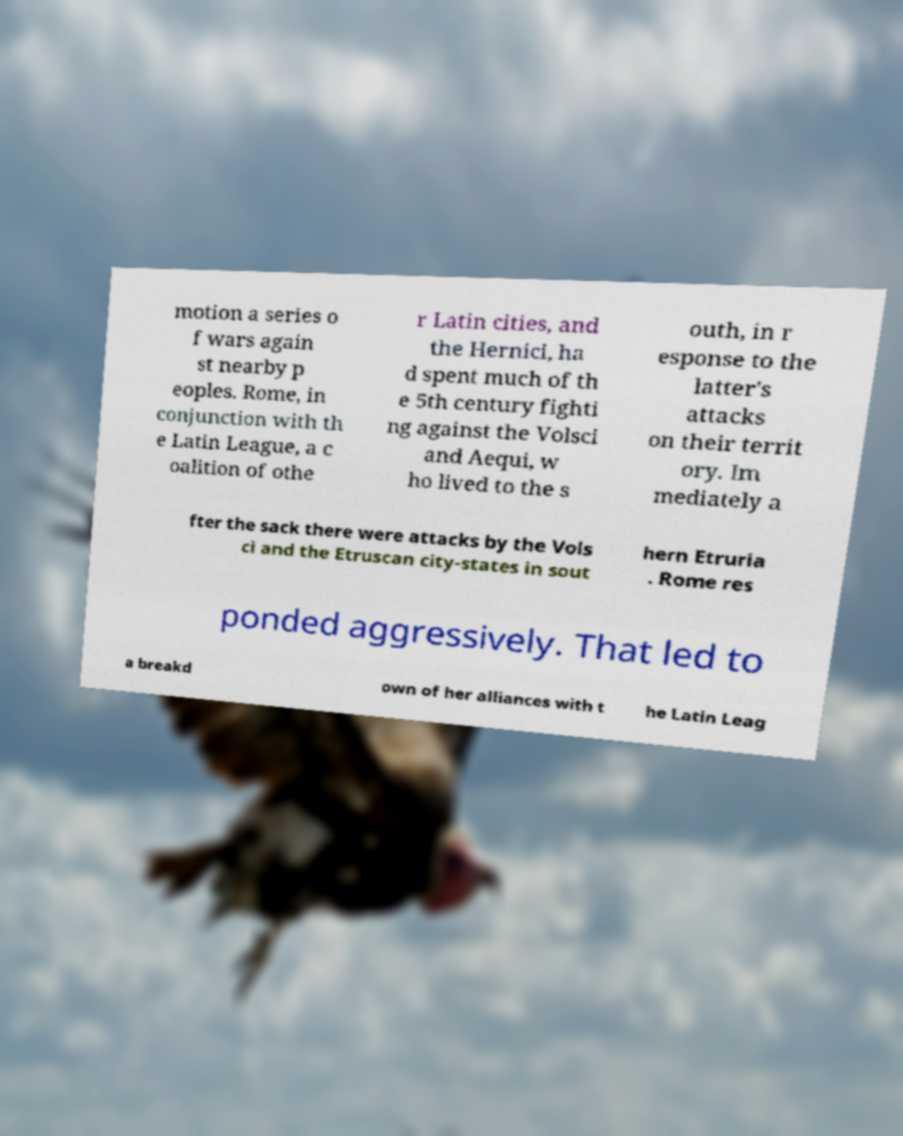Can you accurately transcribe the text from the provided image for me? motion a series o f wars again st nearby p eoples. Rome, in conjunction with th e Latin League, a c oalition of othe r Latin cities, and the Hernici, ha d spent much of th e 5th century fighti ng against the Volsci and Aequi, w ho lived to the s outh, in r esponse to the latter's attacks on their territ ory. Im mediately a fter the sack there were attacks by the Vols ci and the Etruscan city-states in sout hern Etruria . Rome res ponded aggressively. That led to a breakd own of her alliances with t he Latin Leag 